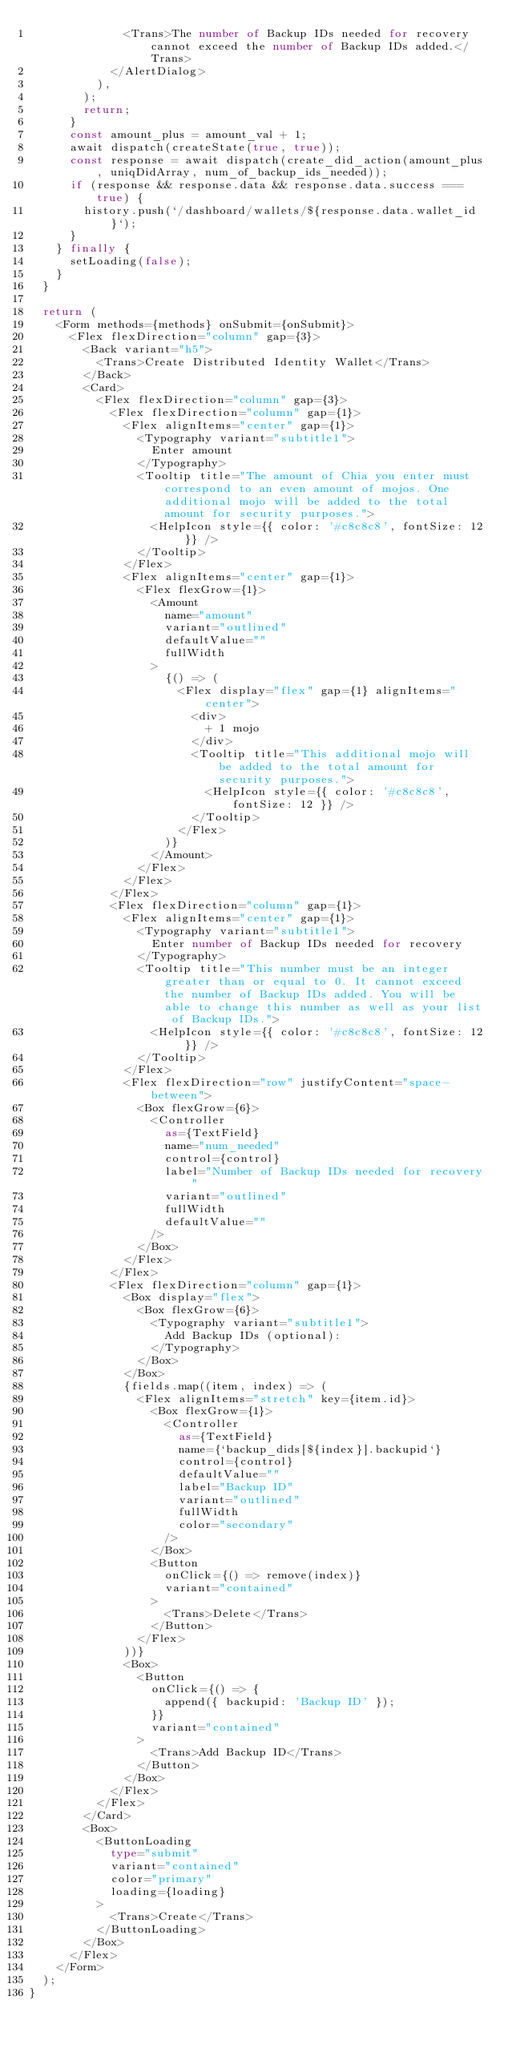<code> <loc_0><loc_0><loc_500><loc_500><_TypeScript_>              <Trans>The number of Backup IDs needed for recovery cannot exceed the number of Backup IDs added.</Trans>
            </AlertDialog>
          ),
        );
        return;
      }
      const amount_plus = amount_val + 1;
      await dispatch(createState(true, true));
      const response = await dispatch(create_did_action(amount_plus, uniqDidArray, num_of_backup_ids_needed));
      if (response && response.data && response.data.success === true) {
        history.push(`/dashboard/wallets/${response.data.wallet_id}`);
      }
    } finally {
      setLoading(false);
    }
  }

  return (
    <Form methods={methods} onSubmit={onSubmit}>
      <Flex flexDirection="column" gap={3}>
        <Back variant="h5">
          <Trans>Create Distributed Identity Wallet</Trans>
        </Back>
        <Card>
          <Flex flexDirection="column" gap={3}>
            <Flex flexDirection="column" gap={1}>
              <Flex alignItems="center" gap={1}>
                <Typography variant="subtitle1">
                  Enter amount
                </Typography>
                <Tooltip title="The amount of Chia you enter must correspond to an even amount of mojos. One additional mojo will be added to the total amount for security purposes.">
                  <HelpIcon style={{ color: '#c8c8c8', fontSize: 12 }} />
                </Tooltip>
              </Flex>
              <Flex alignItems="center" gap={1}>
                <Flex flexGrow={1}>
                  <Amount
                    name="amount"
                    variant="outlined"
                    defaultValue=""
                    fullWidth
                  >
                    {() => (
                      <Flex display="flex" gap={1} alignItems="center">
                        <div>
                          + 1 mojo
                        </div>
                        <Tooltip title="This additional mojo will be added to the total amount for security purposes.">
                          <HelpIcon style={{ color: '#c8c8c8', fontSize: 12 }} />
                        </Tooltip>
                      </Flex>
                    )}
                  </Amount>
                </Flex>
              </Flex>
            </Flex>
            <Flex flexDirection="column" gap={1}>
              <Flex alignItems="center" gap={1}>
                <Typography variant="subtitle1">
                  Enter number of Backup IDs needed for recovery
                </Typography>
                <Tooltip title="This number must be an integer greater than or equal to 0. It cannot exceed the number of Backup IDs added. You will be able to change this number as well as your list of Backup IDs.">
                  <HelpIcon style={{ color: '#c8c8c8', fontSize: 12 }} />
                </Tooltip>
              </Flex>
              <Flex flexDirection="row" justifyContent="space-between">
                <Box flexGrow={6}>
                  <Controller
                    as={TextField}
                    name="num_needed"
                    control={control}
                    label="Number of Backup IDs needed for recovery"
                    variant="outlined"
                    fullWidth
                    defaultValue=""
                  />
                </Box>
              </Flex>
            </Flex>
            <Flex flexDirection="column" gap={1}>
              <Box display="flex">
                <Box flexGrow={6}>
                  <Typography variant="subtitle1">
                    Add Backup IDs (optional):
                  </Typography>
                </Box>
              </Box>
              {fields.map((item, index) => (
                <Flex alignItems="stretch" key={item.id}>
                  <Box flexGrow={1}>
                    <Controller
                      as={TextField}
                      name={`backup_dids[${index}].backupid`}
                      control={control}
                      defaultValue=""
                      label="Backup ID"
                      variant="outlined"
                      fullWidth
                      color="secondary"
                    />
                  </Box>
                  <Button
                    onClick={() => remove(index)}
                    variant="contained"
                  >
                    <Trans>Delete</Trans>
                  </Button>
                </Flex>
              ))}
              <Box>
                <Button
                  onClick={() => {
                    append({ backupid: 'Backup ID' });
                  }}
                  variant="contained"
                >
                  <Trans>Add Backup ID</Trans>
                </Button>
              </Box>
            </Flex>
          </Flex>
        </Card>
        <Box>
          <ButtonLoading
            type="submit"
            variant="contained"
            color="primary"
            loading={loading}
          >
            <Trans>Create</Trans>
          </ButtonLoading>
        </Box>
      </Flex>
    </Form>
  );
}
</code> 